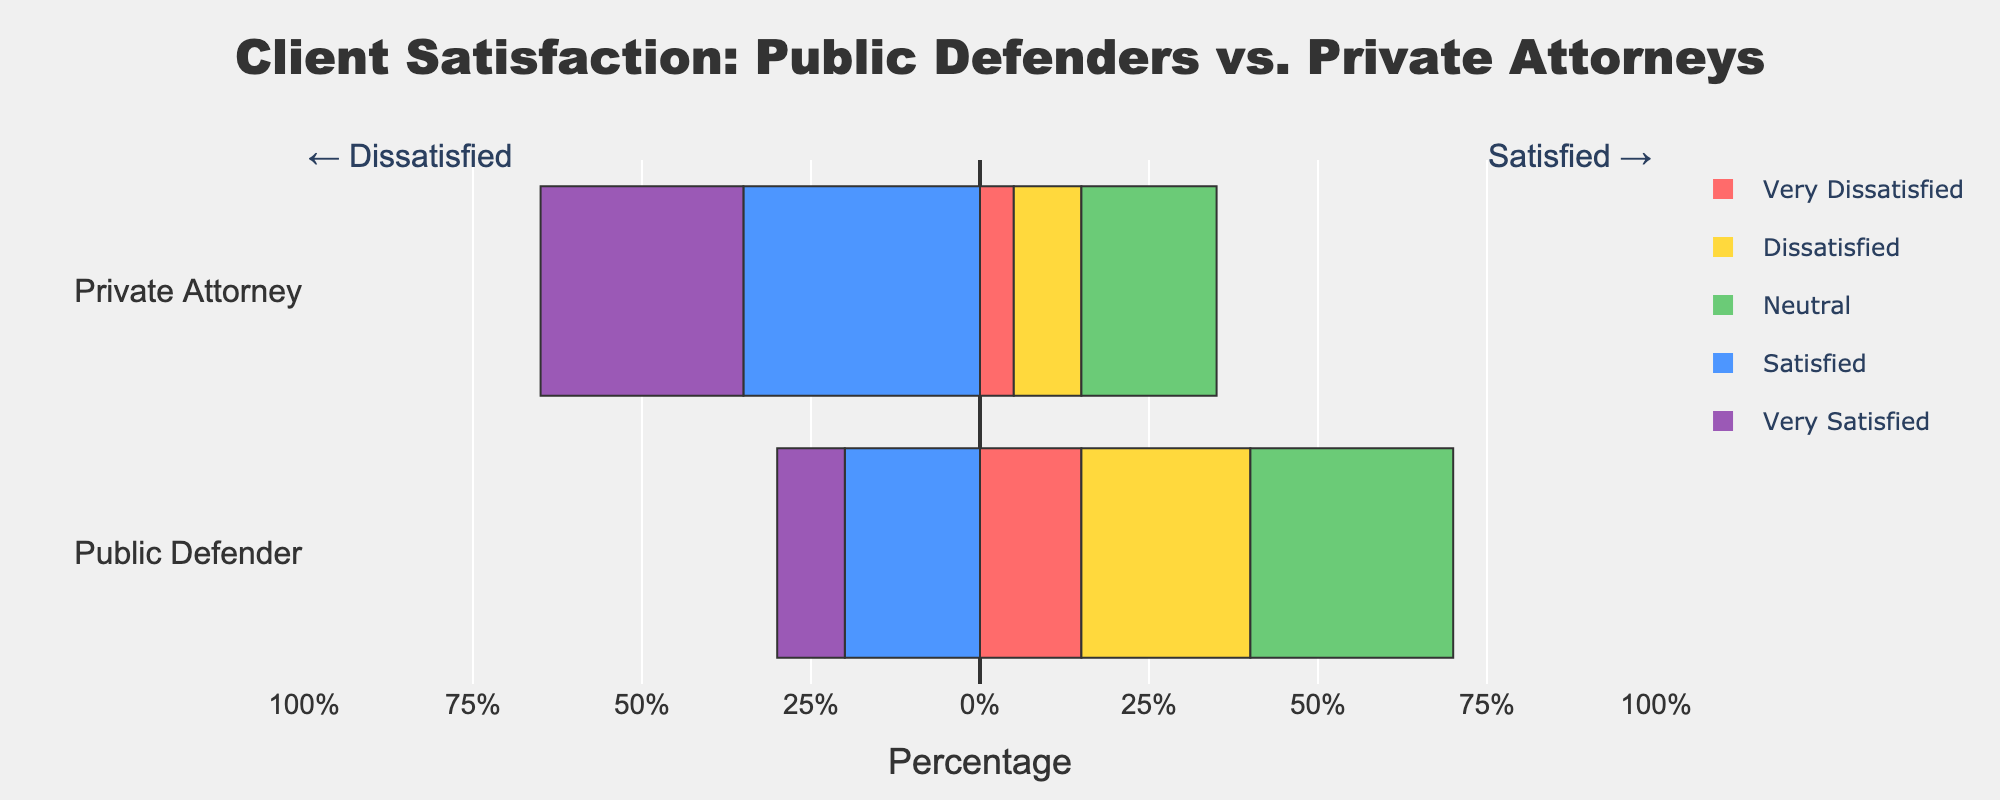What's the percentage of clients who are either satisfied or very satisfied with their private attorneys? To determine this, add the percentages for 'Satisfied' and 'Very Satisfied' categories for private attorneys. These are 35% and 30%, respectively. Thus, the total is 35% + 30% = 65%.
Answer: 65% How does the percentage of 'Very Dissatisfied' clients compare between public defenders and private attorneys? For public defenders, the 'Very Dissatisfied' percentage is 15%, while for private attorneys it is 5%. Therefore, the percentage for public defenders is higher.
Answer: Higher for public defenders Which category of satisfaction has the highest percentage for public defenders? By examining the lengths of the bars, the 'Neutral' category has the greatest length, which signifies the highest percentage. The 'Neutral' percentage for public defenders is 30%.
Answer: Neutral Which service has a higher percentage of dissatisfied clients? 'Dissatisfied' clients include both 'Very Dissatisfied' and 'Dissatisfied' categories. For public defenders: 15% (Very Dissatisfied) + 25% (Dissatisfied) = 40%. For private attorneys: 5% (Very Dissatisfied) + 10% (Dissatisfied) = 15%. Public defenders have a higher percentage of dissatisfied clients.
Answer: Public defenders What is the overall distribution between satisfaction and dissatisfaction for public defenders? Add the percentages for satisfaction-related categories ('Satisfied' and 'Very Satisfied') and dissatisfaction-related categories ('Very Dissatisfied' and 'Dissatisfied'). Satisfaction: 20% (Satisfied) + 10% (Very Satisfied) = 30%. Dissatisfaction: 15% (Very Dissatisfied) + 25% (Dissatisfied) = 40%. Therefore, the distribution is 30% satisfaction and 40% dissatisfaction.
Answer: 30% satisfaction, 40% dissatisfaction Is there any satisfaction category in which private attorneys have a lower percentage than public defenders? By comparing the bars for each category, we notice that private attorneys have lower percentages than public defenders in 'Very Dissatisfied' (5% vs. 15%) and 'Dissatisfied' (10% vs. 25%) categories.
Answer: Yes, in 'Very Dissatisfied' and 'Dissatisfied' How much higher is the proportion of 'Very Satisfied' clients for private attorneys compared to public defenders? The percentage of 'Very Satisfied' clients for private attorneys is 30%, while for public defenders it is 10%. The difference is 30% - 10% = 20%.
Answer: 20% In which service does the 'Satisfied' category make up more than one-third of client feedback? For private attorneys, the 'Satisfied' category is 35%, which is more than one-third (33.33%). For public defenders, it is 20%, which is less than one-third. Therefore, the 'Satisfied' category makes up more than one-third of feedback for private attorneys.
Answer: Private attorneys 